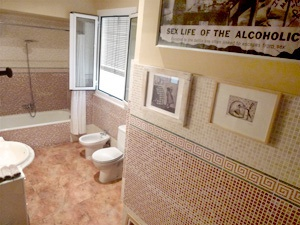Describe the objects in this image and their specific colors. I can see toilet in tan, lightgray, and gray tones, sink in tan, ivory, lightgray, and gray tones, and toilet in tan, lightgray, darkgray, and gray tones in this image. 